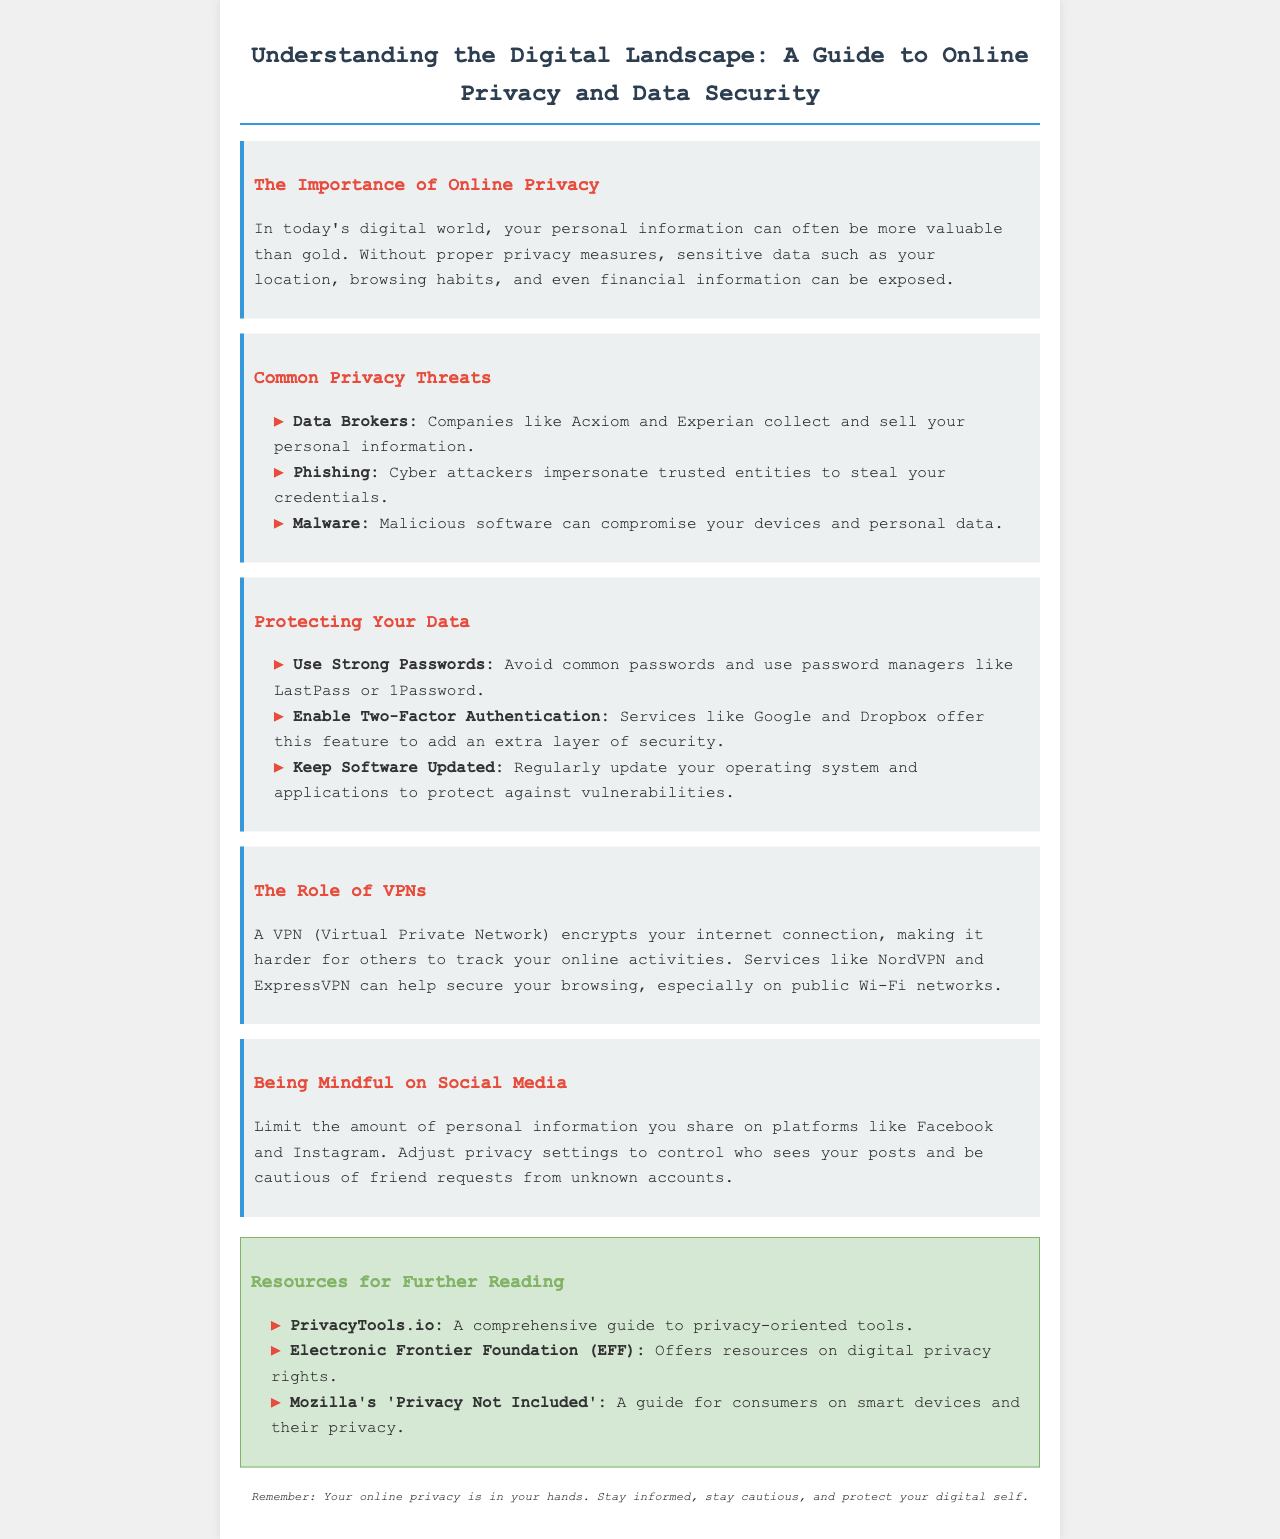What is the title of the brochure? The title can be found at the top of the document.
Answer: Understanding the Digital Landscape: A Guide to Online Privacy and Data Security What is a common privacy threat mentioned? This can be found in the section discussing privacy threats.
Answer: Phishing Which tool is recommended for managing passwords? The document suggests using password managers in the section about protecting data.
Answer: LastPass What does VPN stand for? The abbreviation is explained in the section about VPNs.
Answer: Virtual Private Network What is one way to enhance your social media privacy? This is mentioned in the section about being mindful on social media.
Answer: Adjust privacy settings Name one resource for further reading. The resources section lists several options for further exploration.
Answer: PrivacyTools.io Which two services offer two-factor authentication? The document mentions specific services in the data protection section.
Answer: Google and Dropbox What color is used for the heading of the "Resources for Further Reading" section? The heading uses a specific color in the document's design.
Answer: Green 